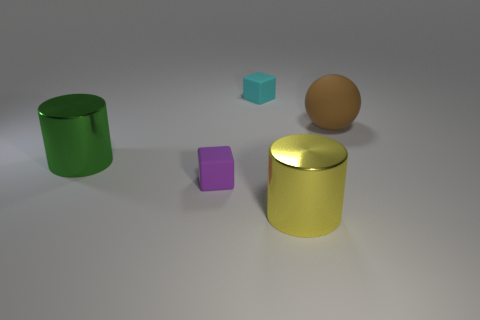There is a small cyan rubber object; is its shape the same as the large metallic object on the right side of the big green cylinder?
Offer a terse response. No. What is the shape of the tiny cyan thing behind the big thing that is in front of the large cylinder that is left of the tiny cyan object?
Ensure brevity in your answer.  Cube. What number of other objects are the same material as the brown object?
Your response must be concise. 2. How many things are either cylinders to the right of the cyan object or purple cubes?
Your response must be concise. 2. What shape is the tiny rubber object that is behind the small matte cube in front of the big green metallic thing?
Your answer should be very brief. Cube. There is a big metal thing left of the cyan rubber cube; is it the same shape as the small cyan matte object?
Make the answer very short. No. There is a matte object that is to the right of the big yellow cylinder; what is its color?
Your answer should be very brief. Brown. How many cubes are large yellow rubber things or big yellow objects?
Keep it short and to the point. 0. What size is the block that is in front of the large object left of the big yellow shiny cylinder?
Offer a terse response. Small. There is a green metallic cylinder; how many large objects are behind it?
Give a very brief answer. 1. 